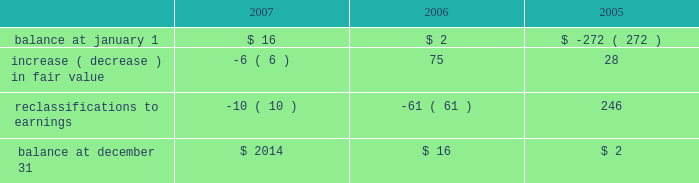The fair value of the interest agreements at december 31 , 2007 and december 31 , 2006 was $ 3 million and $ 1 million , respectively .
The company is exposed to credit loss in the event of nonperformance by the counterparties to its swap contracts .
The company minimizes its credit risk on these transactions by only dealing with leading , creditworthy financial institutions and does not anticipate nonperformance .
In addition , the contracts are distributed among several financial institutions , all of whom presently have investment grade credit ratings , thus minimizing credit risk concentration .
Stockholders 2019 equity derivative instruments activity , net of tax , included in non-owner changes to equity within the consolidated statements of stockholders 2019 equity for the years ended december 31 , 2007 and 2006 is as follows: .
Net investment in foreign operations hedge at december 31 , 2007 and 2006 , the company did not have any hedges of foreign currency exposure of net investments in foreign operations .
Investments hedge during the first quarter of 2006 , the company entered into a zero-cost collar derivative ( the 201csprint nextel derivative 201d ) to protect itself economically against price fluctuations in its 37.6 million shares of sprint nextel corporation ( 201csprint nextel 201d ) non-voting common stock .
During the second quarter of 2006 , as a result of sprint nextel 2019s spin-off of embarq corporation through a dividend to sprint nextel shareholders , the company received approximately 1.9 million shares of embarq corporation .
The floor and ceiling prices of the sprint nextel derivative were adjusted accordingly .
The sprint nextel derivative was not designated as a hedge under the provisions of sfas no .
133 , 201caccounting for derivative instruments and hedging activities . 201d accordingly , to reflect the change in fair value of the sprint nextel derivative , the company recorded a net gain of $ 99 million for the year ended december 31 , 2006 , included in other income ( expense ) in the company 2019s consolidated statements of operations .
In december 2006 , the sprint nextel derivative was terminated and settled in cash and the 37.6 million shares of sprint nextel were converted to common shares and sold .
The company received aggregate cash proceeds of approximately $ 820 million from the settlement of the sprint nextel derivative and the subsequent sale of the 37.6 million sprint nextel shares .
The company recognized a loss of $ 126 million in connection with the sale of the remaining shares of sprint nextel common stock .
As described above , the company recorded a net gain of $ 99 million in connection with the sprint nextel derivative .
Prior to the merger of sprint corporation ( 201csprint 201d ) and nextel communications , inc .
( 201cnextel 201d ) , the company had entered into variable share forward purchase agreements ( the 201cvariable forwards 201d ) to hedge its nextel common stock .
The company did not designate the variable forwards as a hedge of the sprint nextel shares received as a result of the merger .
Accordingly , the company recorded $ 51 million of gains for the year ended december 31 , 2005 reflecting the change in value of the variable forwards .
The variable forwards were settled during the fourth quarter of 2005 .
Fair value of financial instruments the company 2019s financial instruments include cash equivalents , sigma fund investments , short-term investments , accounts receivable , long-term finance receivables , accounts payable , accrued liabilities , derivatives and other financing commitments .
The company 2019s sigma fund and investment portfolios and derivatives are recorded in the company 2019s consolidated balance sheets at fair value .
All other financial instruments , with the exception of long-term debt , are carried at cost , which is not materially different than the instruments 2019 fair values. .
What is the percent change in increase of fair value between 2005 and 2006? 
Computations: ((75 - 28) / 28)
Answer: 1.67857. 